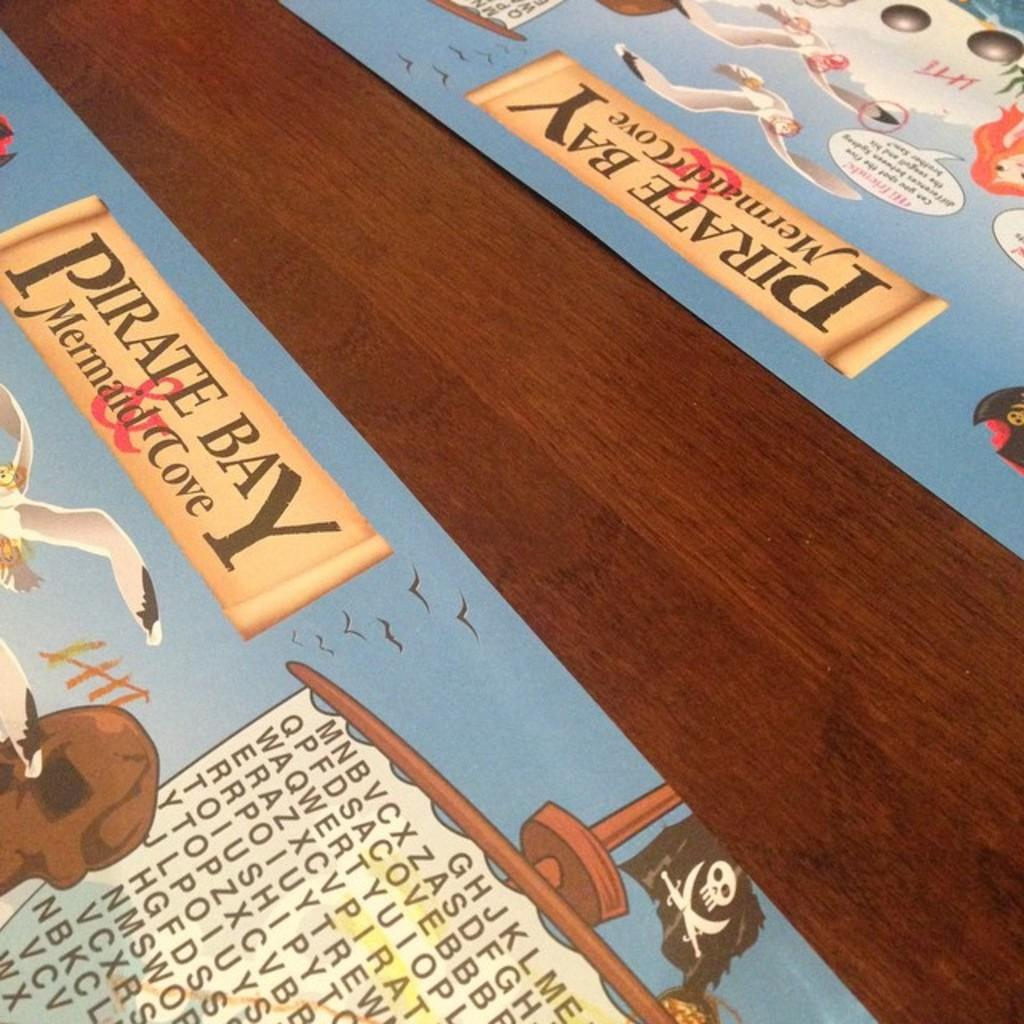<image>
Relay a brief, clear account of the picture shown. A wood table with two placemats from Pirate Bay Mermaid Cove with games such as word searches on them. 